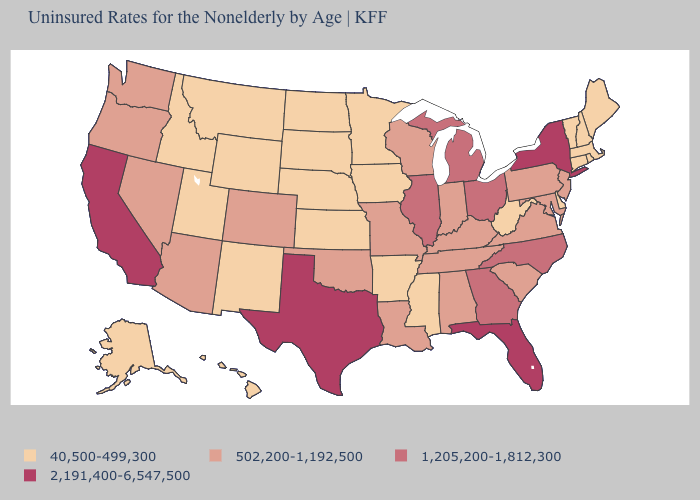Is the legend a continuous bar?
Write a very short answer. No. Name the states that have a value in the range 1,205,200-1,812,300?
Give a very brief answer. Georgia, Illinois, Michigan, North Carolina, Ohio. What is the value of Wyoming?
Quick response, please. 40,500-499,300. Is the legend a continuous bar?
Answer briefly. No. What is the value of South Carolina?
Concise answer only. 502,200-1,192,500. What is the value of Nevada?
Give a very brief answer. 502,200-1,192,500. What is the lowest value in the South?
Give a very brief answer. 40,500-499,300. Among the states that border Missouri , which have the lowest value?
Keep it brief. Arkansas, Iowa, Kansas, Nebraska. Name the states that have a value in the range 1,205,200-1,812,300?
Give a very brief answer. Georgia, Illinois, Michigan, North Carolina, Ohio. What is the value of Colorado?
Keep it brief. 502,200-1,192,500. What is the value of Nevada?
Keep it brief. 502,200-1,192,500. What is the value of Virginia?
Quick response, please. 502,200-1,192,500. What is the lowest value in the MidWest?
Short answer required. 40,500-499,300. What is the value of Maine?
Give a very brief answer. 40,500-499,300. What is the value of Rhode Island?
Quick response, please. 40,500-499,300. 